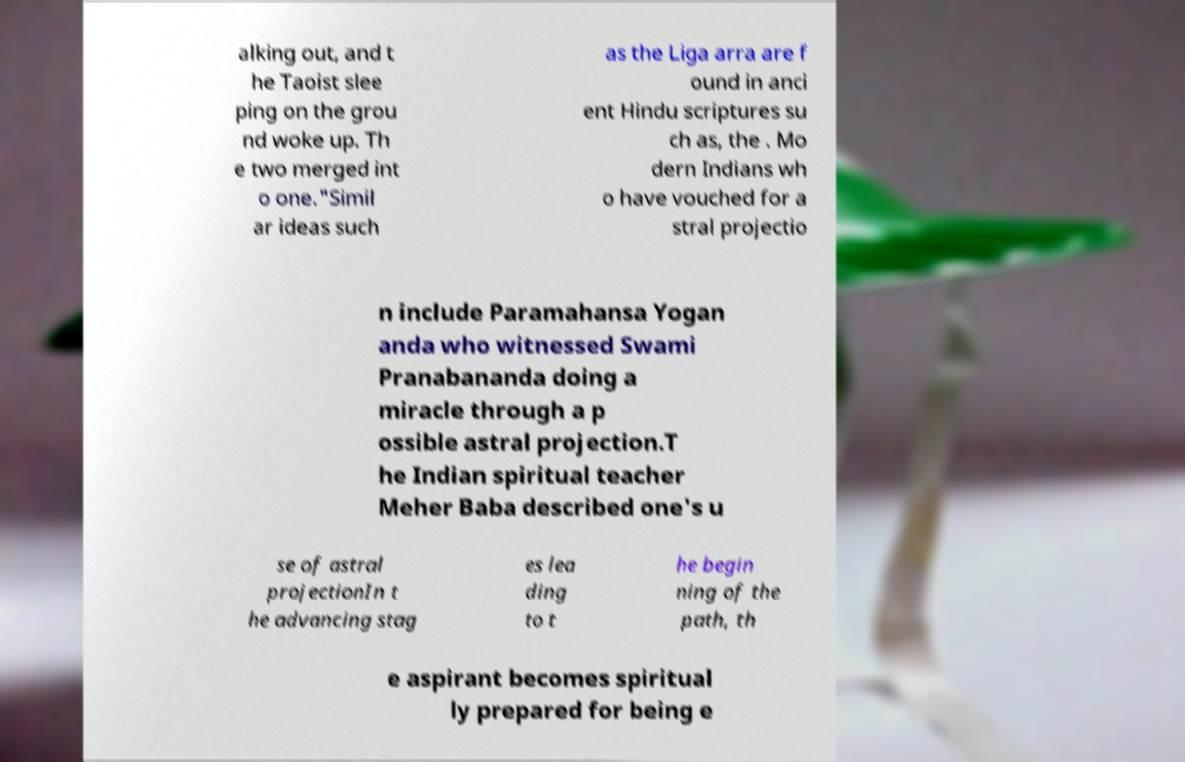Could you assist in decoding the text presented in this image and type it out clearly? alking out, and t he Taoist slee ping on the grou nd woke up. Th e two merged int o one."Simil ar ideas such as the Liga arra are f ound in anci ent Hindu scriptures su ch as, the . Mo dern Indians wh o have vouched for a stral projectio n include Paramahansa Yogan anda who witnessed Swami Pranabananda doing a miracle through a p ossible astral projection.T he Indian spiritual teacher Meher Baba described one's u se of astral projectionIn t he advancing stag es lea ding to t he begin ning of the path, th e aspirant becomes spiritual ly prepared for being e 